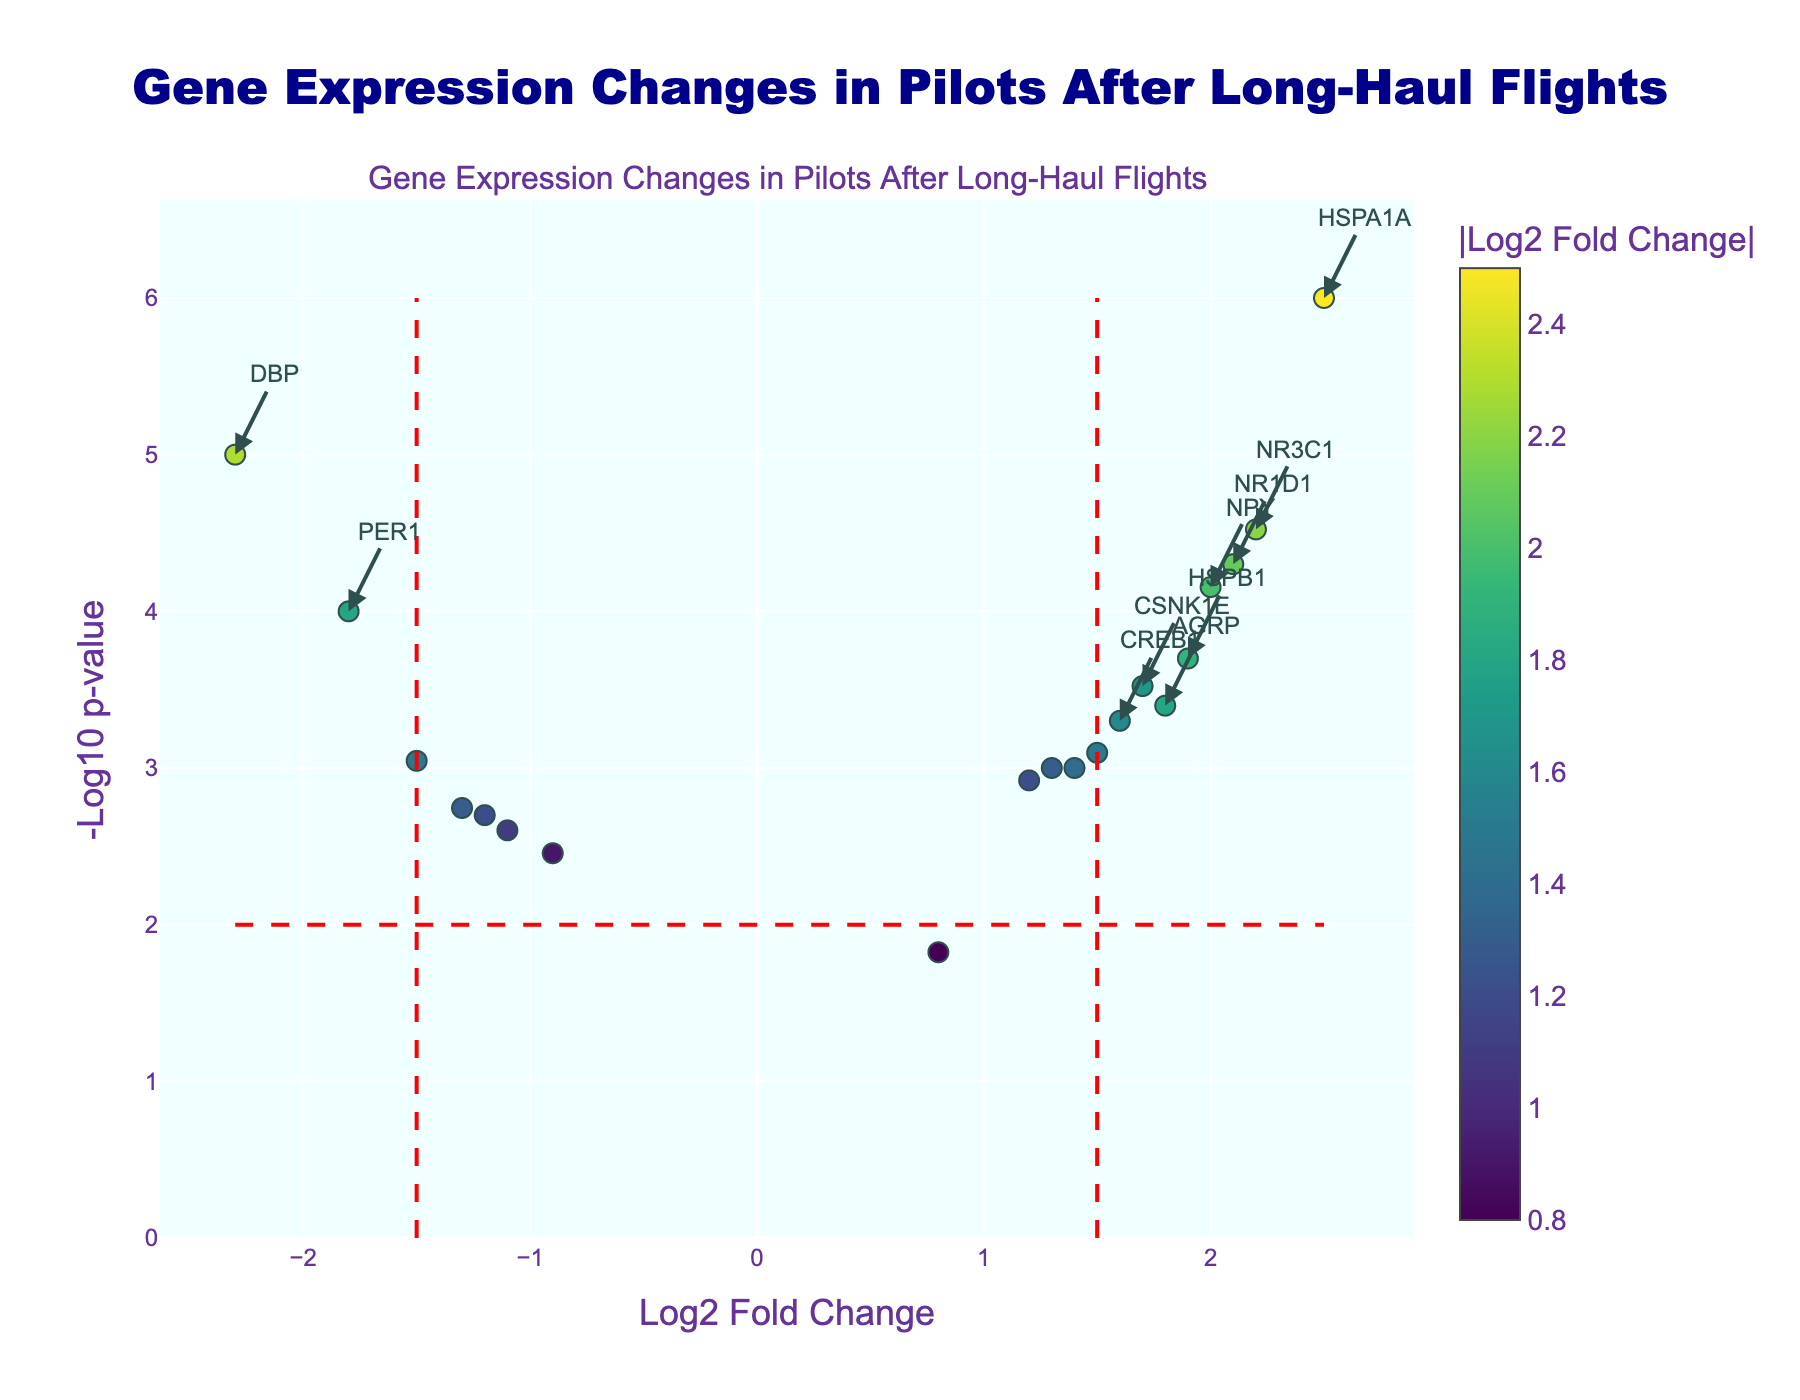what is the title of the plot? The title can be found at the top of the figure. It summarizes the dataset and the context of the plot.
Answer: Gene Expression Changes in Pilots After Long-Haul Flights Which genes have a significantly higher expression level after long-haul flights? Genes with significantly higher expression levels have a high log2 fold change and a low p-value (above the horizontal red line and to the right of the vertical red line).
Answer: NR1D1, HSPA1A, HSPB1, CSNK1E, NPY, CREB1, NR3C1, AGRP, CLOCK, SLC6A4, CRY1 Which gene has the highest change in expression level and what is its name? Look for the gene with the highest absolute log2 fold change value, which is represented as the largest horizontal shift from the origin.
Answer: HSPA1A How many genes in total are highlighted as significant changes in expression? Count the number of annotations indicating significant changes due to being above the fold change and p-value thresholds.
Answer: 11 Which gene shows the most significant decrease in expression level, and what is its log2 fold change? Find the gene with the lowest log2 fold change (most negative value) that also lies above the p-value threshold.
Answer: DBP, -2.3 Compare the expression changes between PER1 and CRY1. Which one has a larger magnitude change? Check the log2 fold change values of PER1 and CRY1 and compare their absolute values.
Answer: PER1 has a larger magnitude change What colors are used to represent the different levels of log2 fold change, and what does a darker color indicate? Observe the color scale on the plot and deduce what darker colors represent as per the color legend.
Answer: Shades in the Viridis color scale, darker colors indicate higher absolute log2 fold change Is there a gene related to both circadian rhythm and stress, and if so, which one shows a significant increase after flights? Identify genes associated with both circadian rhythm and stress that lie beyond the significance thresholds of fold change and p-value.
Answer: HSPA1A What can you say about the overall trend in gene expression changes related to circadian rhythm? Look for the general pattern of circadian rhythm-related genes, whether they show increased or decreased expression predominantly.
Answer: Mixed changes with some genes like NR1D1 and CRY1 increasing and others like PER1 and DBP decreasing Which gene related to circadian rhythm had the smallest change in expression, and what was its log2 fold change? Find the circadian-related gene with the smallest absolute log2 fold change using the legend and annotation.
Answer: NPAS2, 0.8 